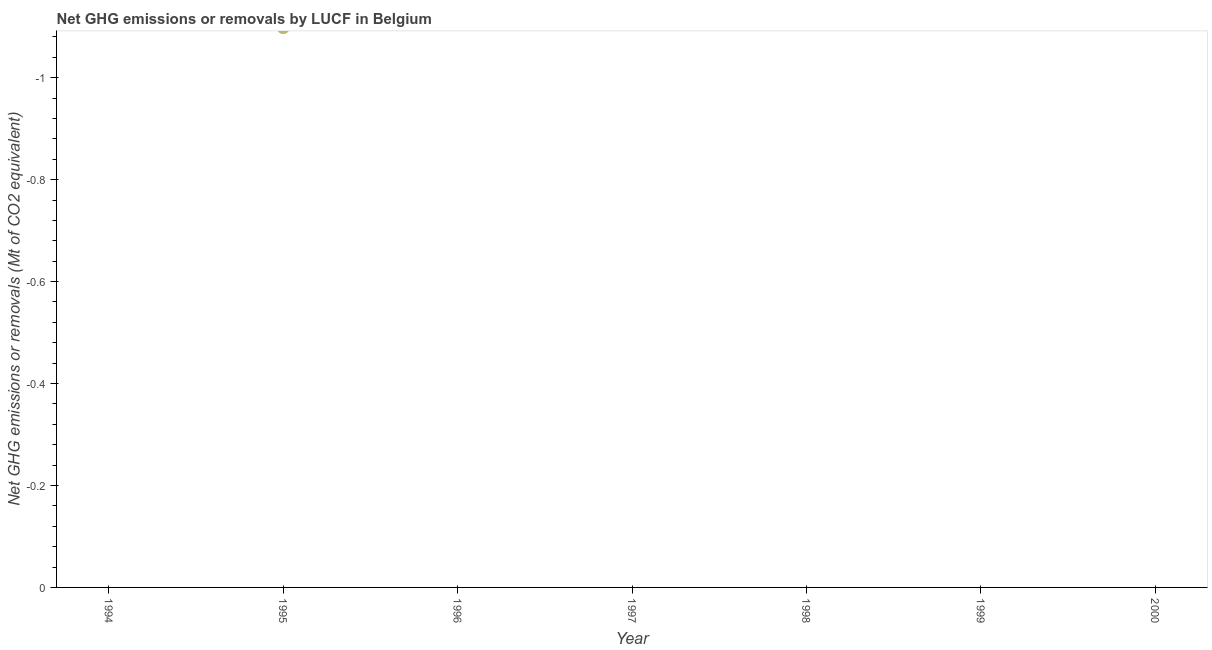What is the ghg net emissions or removals in 1998?
Offer a very short reply. 0. What is the sum of the ghg net emissions or removals?
Make the answer very short. 0. What is the median ghg net emissions or removals?
Provide a short and direct response. 0. In how many years, is the ghg net emissions or removals greater than the average ghg net emissions or removals taken over all years?
Your answer should be very brief. 0. Does the ghg net emissions or removals monotonically increase over the years?
Offer a very short reply. No. How many dotlines are there?
Your answer should be compact. 0. What is the difference between two consecutive major ticks on the Y-axis?
Your answer should be very brief. 0.2. Does the graph contain any zero values?
Keep it short and to the point. Yes. Does the graph contain grids?
Make the answer very short. No. What is the title of the graph?
Your response must be concise. Net GHG emissions or removals by LUCF in Belgium. What is the label or title of the X-axis?
Give a very brief answer. Year. What is the label or title of the Y-axis?
Make the answer very short. Net GHG emissions or removals (Mt of CO2 equivalent). What is the Net GHG emissions or removals (Mt of CO2 equivalent) in 1994?
Your response must be concise. 0. What is the Net GHG emissions or removals (Mt of CO2 equivalent) in 1997?
Offer a terse response. 0. What is the Net GHG emissions or removals (Mt of CO2 equivalent) in 1998?
Give a very brief answer. 0. 